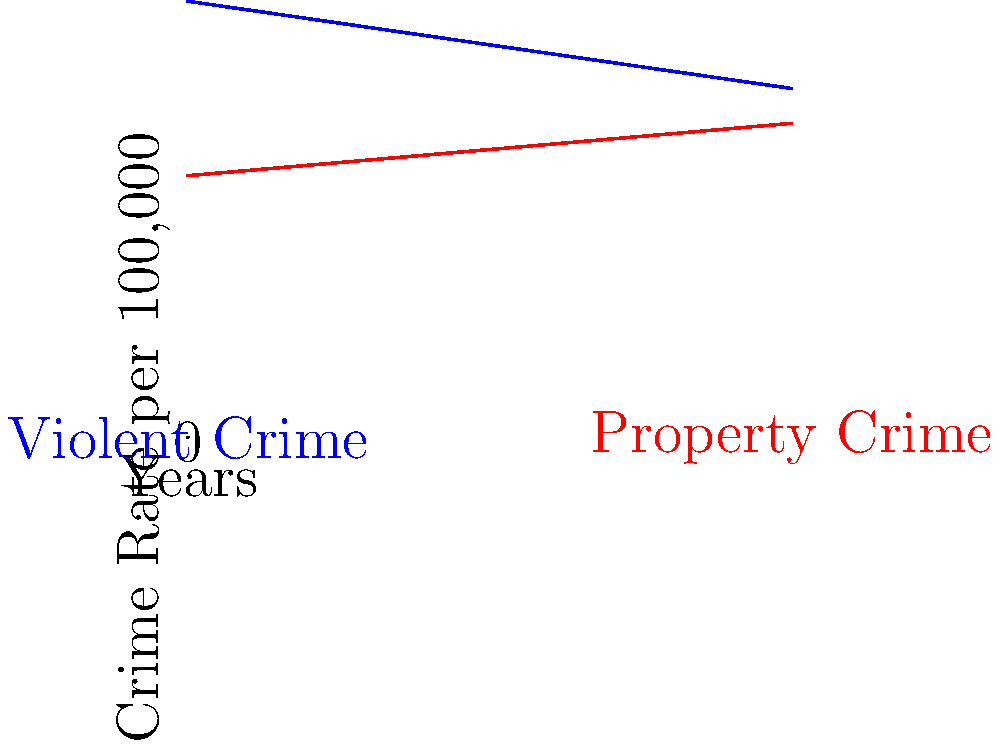As an incumbent judge, how would you interpret the trends shown in this graph, and how might they reflect on your effectiveness in office over the past decade? 1. Analyze the graph:
   - The blue line represents violent crime, which is decreasing over time.
   - The red line represents property crime, which is increasing over time.
   - The x-axis spans 10 years, suggesting this is a decade-long trend.

2. Interpret the violent crime trend:
   - The rate of violent crime has decreased from about 25 per 100,000 to about 20 per 100,000 over 10 years.
   - This represents a significant improvement in public safety.

3. Interpret the property crime trend:
   - The rate of property crime has increased from about 15 per 100,000 to about 18 per 100,000 over 10 years.
   - This suggests a need for increased focus on preventing property crimes.

4. Consider the overall impact:
   - The decrease in violent crime outweighs the increase in property crime in terms of severity.
   - The net effect could be interpreted as an overall improvement in public safety.

5. Relate to judicial effectiveness:
   - The reduction in violent crime could be attributed to effective sentencing and rehabilitation programs.
   - The increase in property crime might be due to factors outside judicial control, such as economic conditions.

6. Address potential criticisms:
   - While property crime has increased, the rate of increase is slower than the rate of decrease for violent crime.
   - The overall crime situation has improved, with a focus on reducing more serious offenses.

7. Conclude with a positive interpretation:
   - The trends show a significant improvement in public safety, particularly regarding violent crimes.
   - This supports the effectiveness of the current judicial approach and sentencing practices.
Answer: Overall crime situation improved; violent crime significantly reduced, outweighing slight increase in property crime. 